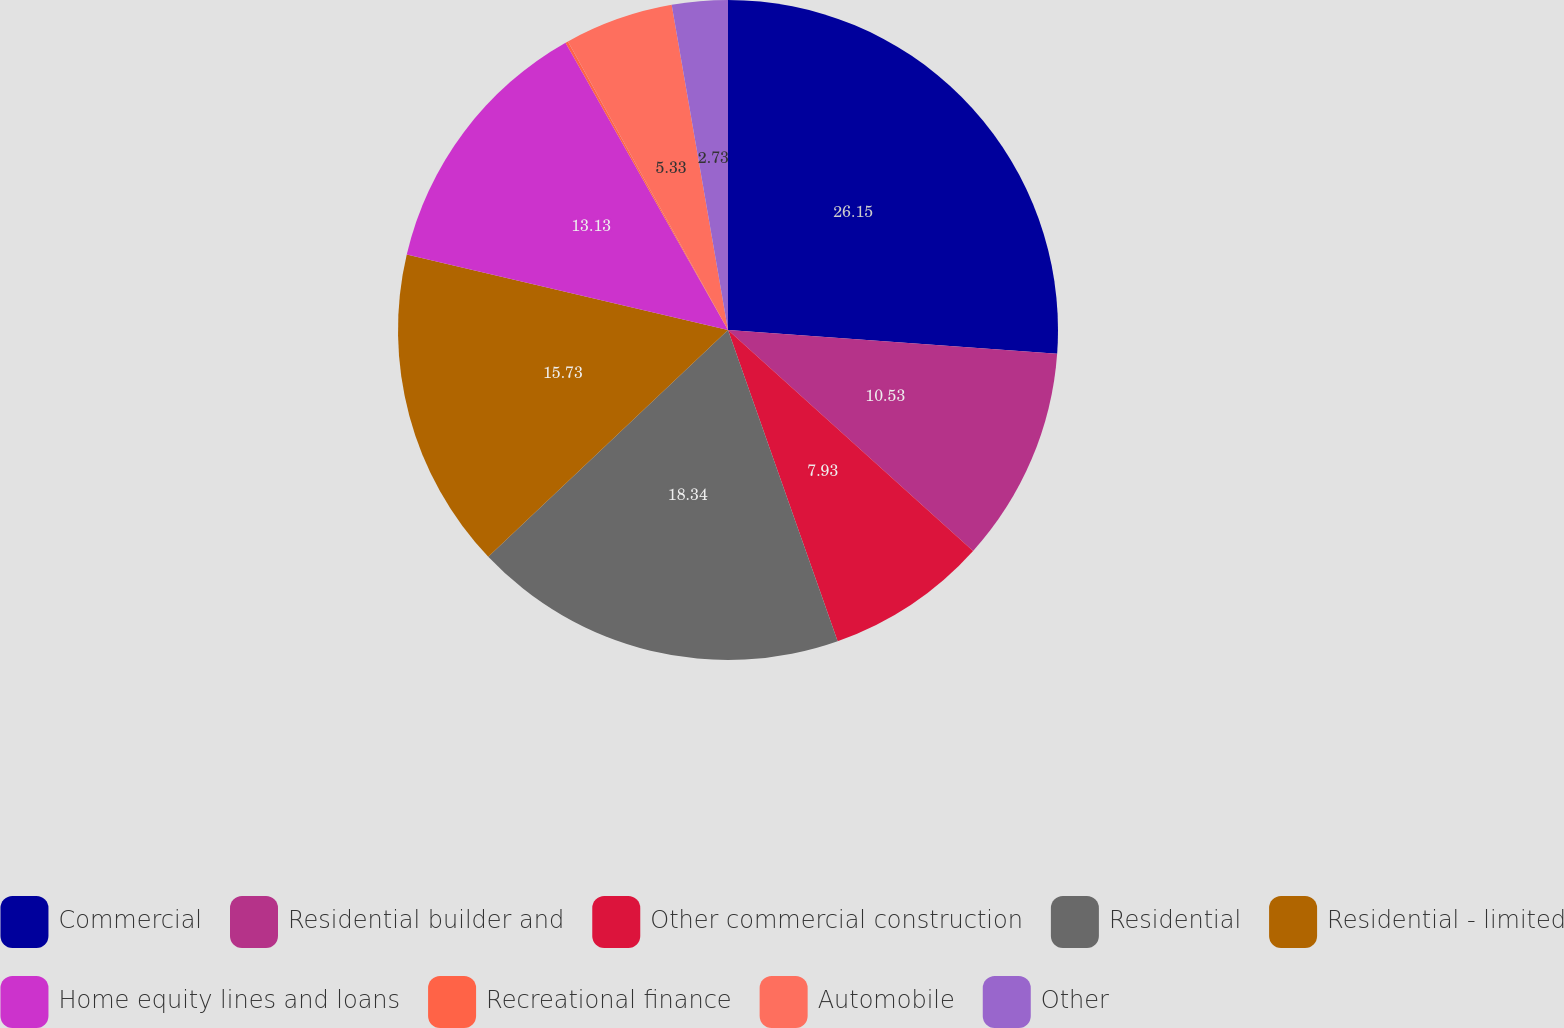Convert chart. <chart><loc_0><loc_0><loc_500><loc_500><pie_chart><fcel>Commercial<fcel>Residential builder and<fcel>Other commercial construction<fcel>Residential<fcel>Residential - limited<fcel>Home equity lines and loans<fcel>Recreational finance<fcel>Automobile<fcel>Other<nl><fcel>26.14%<fcel>10.53%<fcel>7.93%<fcel>18.33%<fcel>15.73%<fcel>13.13%<fcel>0.13%<fcel>5.33%<fcel>2.73%<nl></chart> 